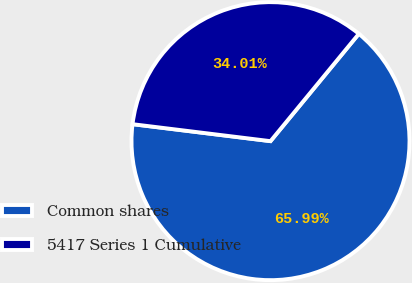Convert chart to OTSL. <chart><loc_0><loc_0><loc_500><loc_500><pie_chart><fcel>Common shares<fcel>5417 Series 1 Cumulative<nl><fcel>65.99%<fcel>34.01%<nl></chart> 